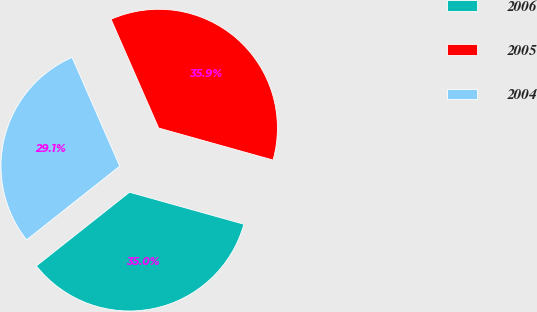<chart> <loc_0><loc_0><loc_500><loc_500><pie_chart><fcel>2006<fcel>2005<fcel>2004<nl><fcel>35.0%<fcel>35.91%<fcel>29.09%<nl></chart> 